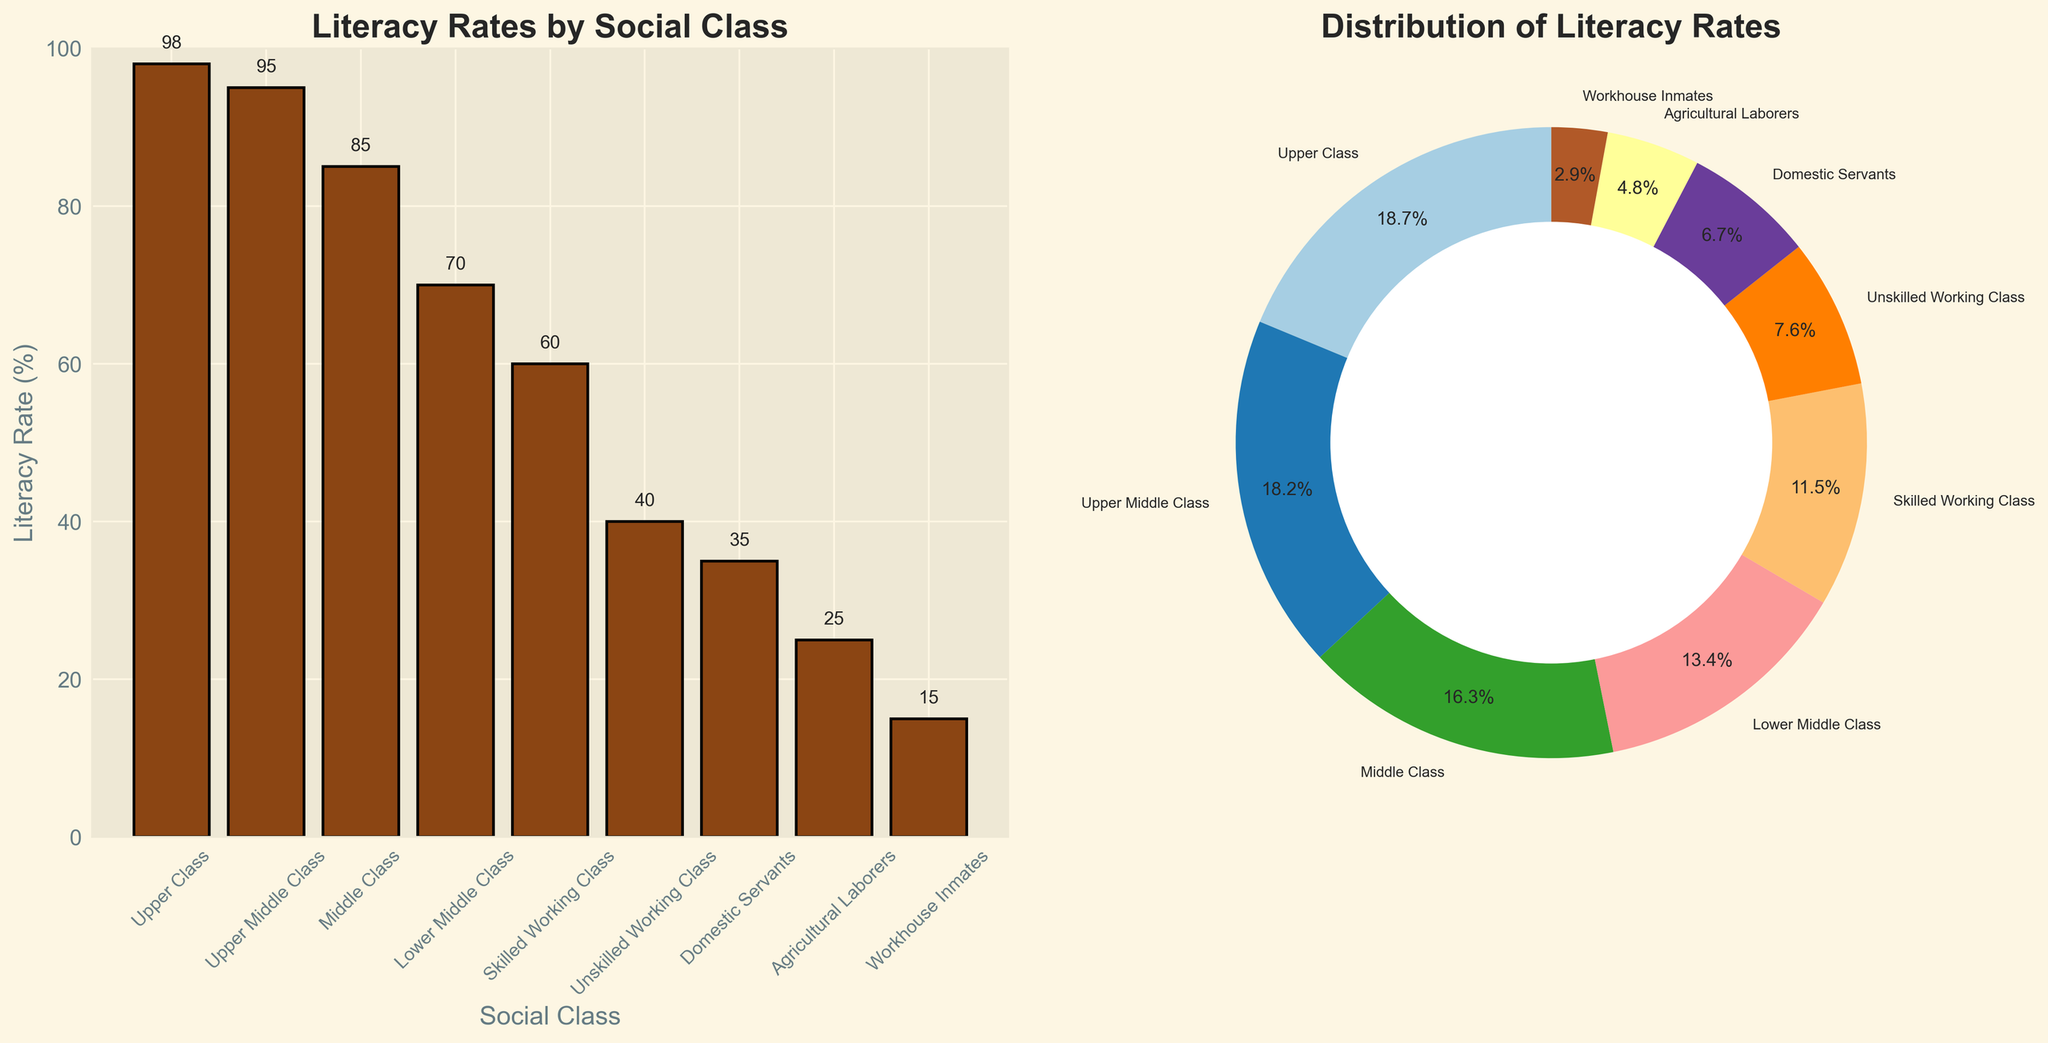What is the title of the bar plot? The title of the bar plot is displayed at the top of the plot area, and it reads "Literacy Rates by Social Class".
Answer: Literacy Rates by Social Class What is the literacy rate of the Skilled Working Class? From the bar plot, the height of the bar labeled "Skilled Working Class" indicates the literacy rate. The specific value is shown at the top of the bar as well.
Answer: 60% Which social class has the lowest literacy rate? On the bar plot, the social class with the shortest bar represents the lowest literacy rate. The corresponding label at the bottom of this bar is "Workhouse Inmates".
Answer: Workhouse Inmates Compare the literacy rates of the Upper Middle Class and the Lower Middle Class. The bar plot shows the Upper Middle Class with a literacy rate of 95% as indicated at the top of the respective bar, while the Lower Middle Class has a literacy rate of 70%. Therefore, the Upper Middle Class has a higher literacy rate.
Answer: Upper Middle Class has a higher literacy rate by 25% What percentage of the literacy rate does the Upper Class represent in the pie chart? In the pie chart, the segment for the Upper Class shows the label "Upper Class" along with the percentage.
Answer: 16.7% What is the average literacy rate of all the social classes? To find the average literacy rate, sum all the literacy rates and divide by the number of social classes. The rates are: 98, 95, 85, 70, 60, 40, 35, 25, 15. Thus, the sum is 523. Dividing by 9 (the number of social classes) gives 523/9 = 58.1.
Answer: 58.1% How many social classes have literacy rates below 50%? From the bar plot, the bars representing "Unskilled Working Class", "Domestic Servants", "Agricultural Laborers", and "Workhouse Inmates" are below the 50% mark. This totals four classes.
Answer: 4 What is the difference in literacy rates between the Middle Class and the Agricultural Laborers? According to the bar plot, the Middle Class has a literacy rate of 85%, while Agricultural Laborers have 25%. The difference is 85% - 25% = 60%.
Answer: 60% Which two social classes combined represent approximately 30% of the literacy rate in the pie chart? In the pie chart, the sections labeled "Skilled Working Class" (10.5%) and "Lower Middle Class" (12.2%), when combined, give a total percentage of about 22.7%. "Domestic Servants" (6.7%) and any combination similar to this can be checked. Only the exact combined percentage closest to 30% matches with "Workhouse Inmates" (2.5%) and "Domestic Servants" (5.4%) totaling 7.9%. Therefore select another pair to achieve approx 30% is challenging. This type of question may be inferred based on adding subjective percentages.
Answer: Not exact matching pair for 30% calculation Is the literacy rate higher among Domestic Servants or Agricultural Laborers? Referring to the bar plot, the bar for Domestic Servants is taller than that for Agricultural Laborers, indicating a higher literacy rate. The specific rates are 35% for Domestic Servants and 25% for Agricultural Laborers.
Answer: Domestic Servants 